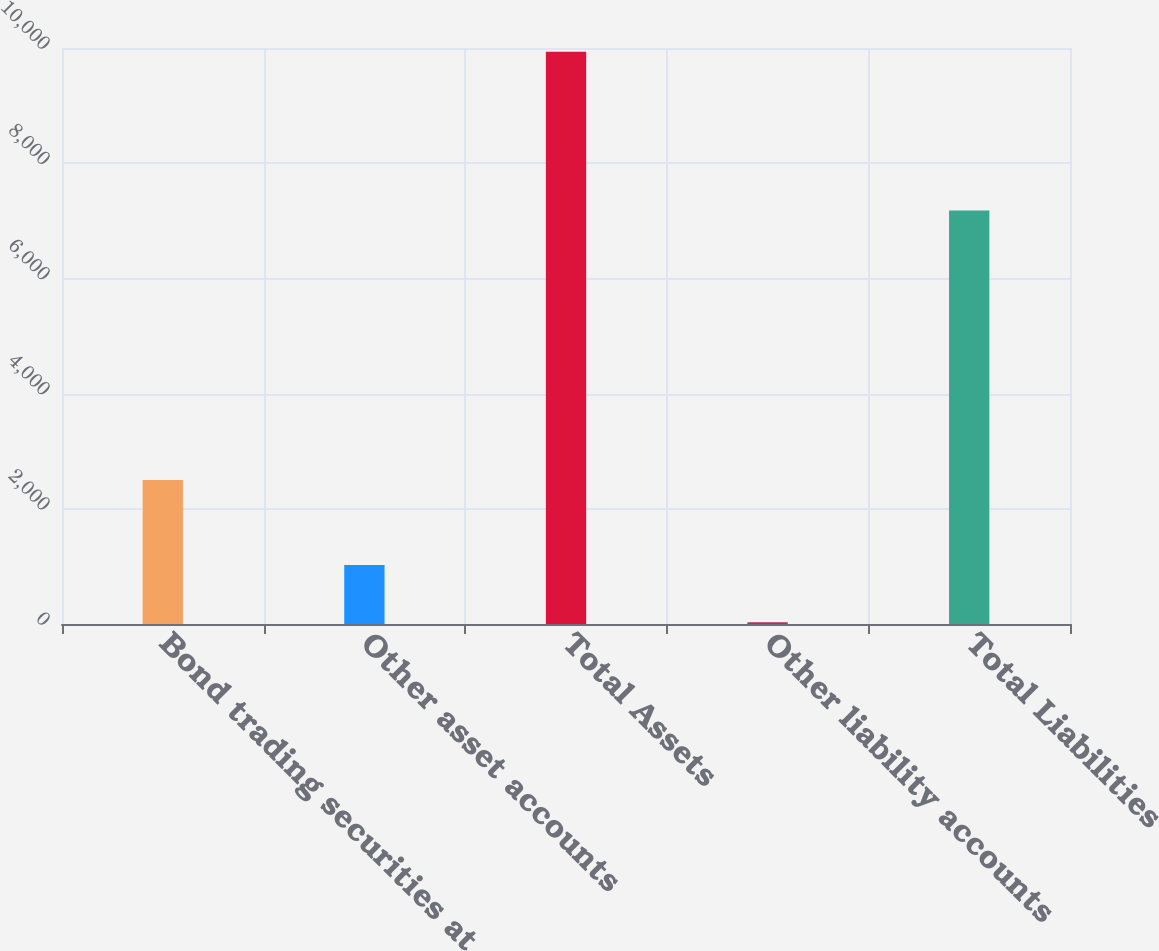Convert chart to OTSL. <chart><loc_0><loc_0><loc_500><loc_500><bar_chart><fcel>Bond trading securities at<fcel>Other asset accounts<fcel>Total Assets<fcel>Other liability accounts<fcel>Total Liabilities<nl><fcel>2501<fcel>1022.3<fcel>9935<fcel>32<fcel>7178<nl></chart> 